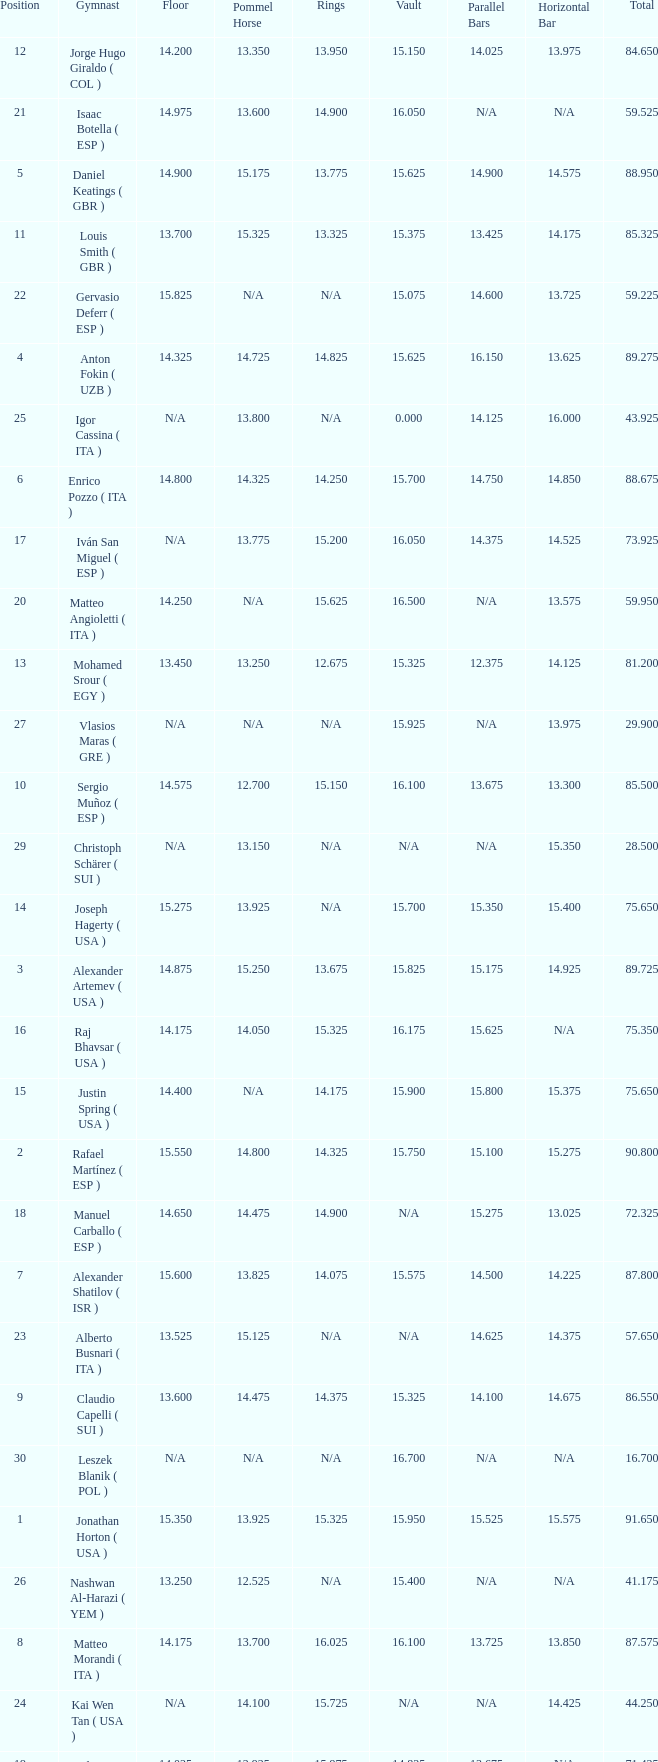If the parallel bars is 16.150, who is the gymnast? Anton Fokin ( UZB ). 